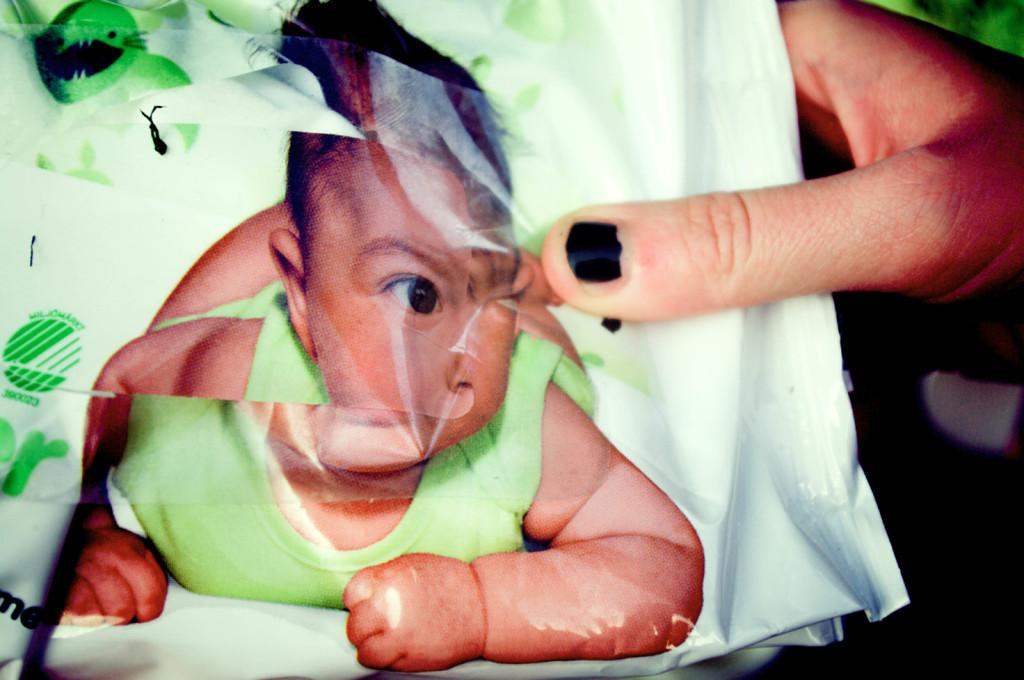What is the main object in the image? There is a plastic cover in the image. What is depicted on the plastic cover? There is an image of a baby on the cover. Can you describe the human presence in the image? There is a human hand on the right side of the image. What type of fruit is being worked on in the image? There is no fruit or work-related activity present in the image. 